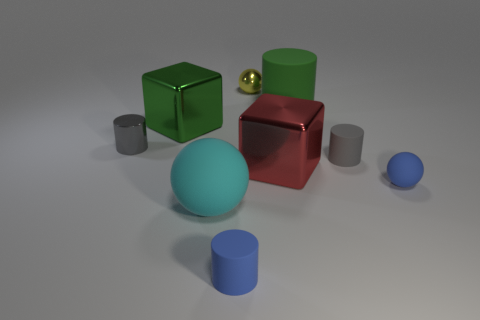Add 1 tiny gray shiny blocks. How many objects exist? 10 Subtract all balls. How many objects are left? 6 Subtract all gray metal cylinders. Subtract all blue rubber objects. How many objects are left? 6 Add 8 tiny gray metallic objects. How many tiny gray metallic objects are left? 9 Add 1 blue matte balls. How many blue matte balls exist? 2 Subtract 0 red balls. How many objects are left? 9 